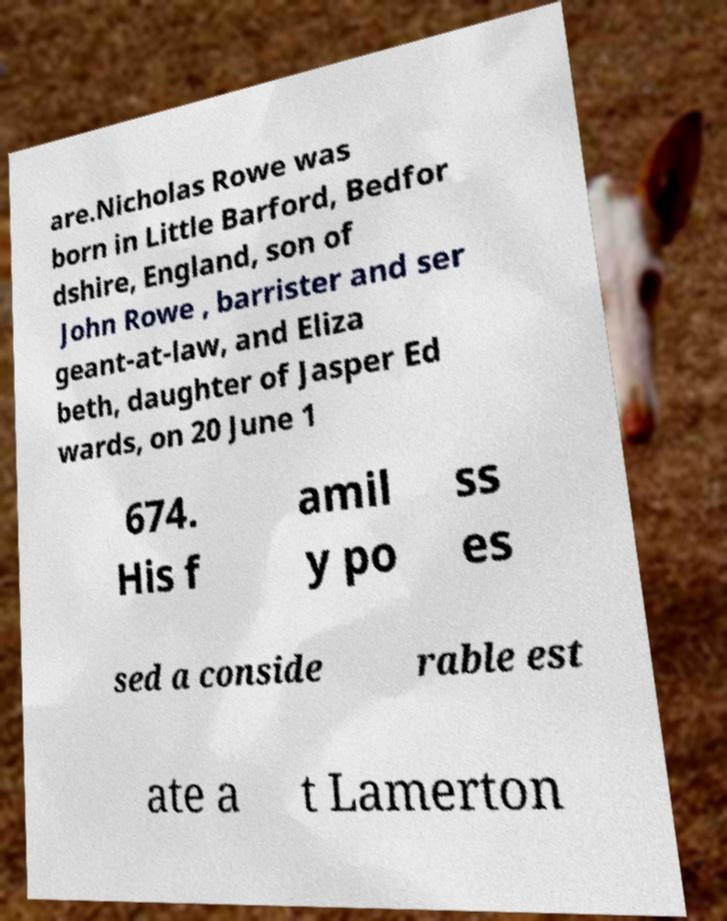Please read and relay the text visible in this image. What does it say? are.Nicholas Rowe was born in Little Barford, Bedfor dshire, England, son of John Rowe , barrister and ser geant-at-law, and Eliza beth, daughter of Jasper Ed wards, on 20 June 1 674. His f amil y po ss es sed a conside rable est ate a t Lamerton 